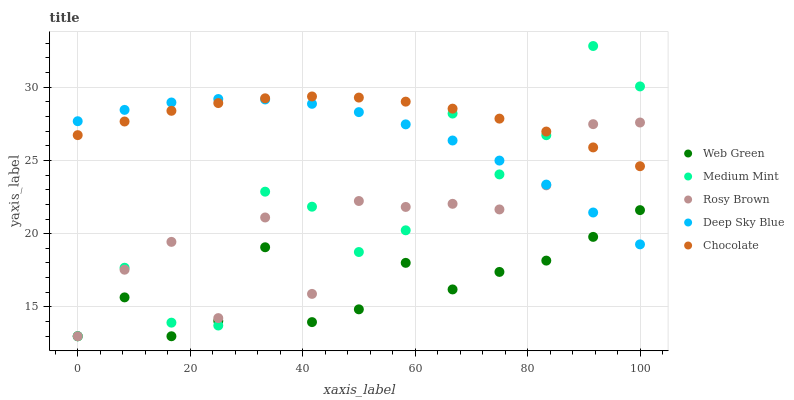Does Web Green have the minimum area under the curve?
Answer yes or no. Yes. Does Chocolate have the maximum area under the curve?
Answer yes or no. Yes. Does Rosy Brown have the minimum area under the curve?
Answer yes or no. No. Does Rosy Brown have the maximum area under the curve?
Answer yes or no. No. Is Chocolate the smoothest?
Answer yes or no. Yes. Is Medium Mint the roughest?
Answer yes or no. Yes. Is Rosy Brown the smoothest?
Answer yes or no. No. Is Rosy Brown the roughest?
Answer yes or no. No. Does Medium Mint have the lowest value?
Answer yes or no. Yes. Does Deep Sky Blue have the lowest value?
Answer yes or no. No. Does Medium Mint have the highest value?
Answer yes or no. Yes. Does Rosy Brown have the highest value?
Answer yes or no. No. Is Web Green less than Chocolate?
Answer yes or no. Yes. Is Chocolate greater than Web Green?
Answer yes or no. Yes. Does Medium Mint intersect Deep Sky Blue?
Answer yes or no. Yes. Is Medium Mint less than Deep Sky Blue?
Answer yes or no. No. Is Medium Mint greater than Deep Sky Blue?
Answer yes or no. No. Does Web Green intersect Chocolate?
Answer yes or no. No. 